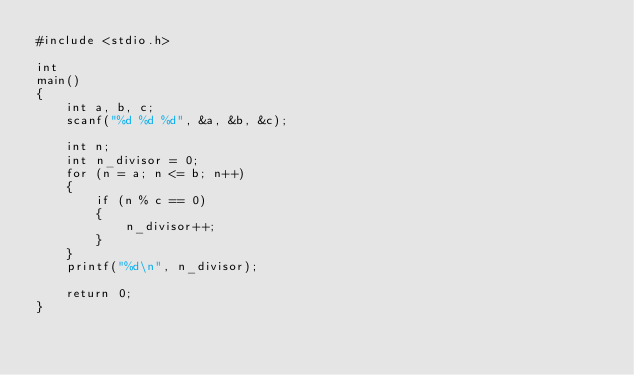<code> <loc_0><loc_0><loc_500><loc_500><_C_>#include <stdio.h>

int
main()
{
	int a, b, c;
	scanf("%d %d %d", &a, &b, &c);

	int n;
	int n_divisor = 0;
	for (n = a; n <= b; n++)
	{
		if (n % c == 0)
		{
			n_divisor++;
		}
	}
	printf("%d\n", n_divisor);

	return 0;
}</code> 